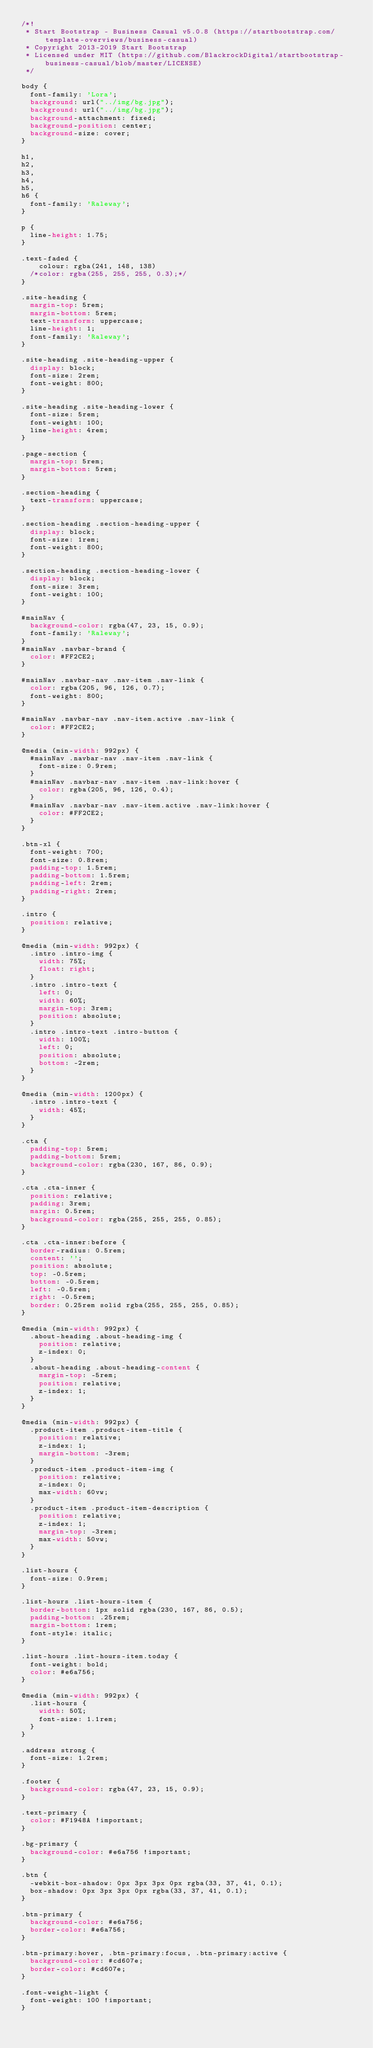Convert code to text. <code><loc_0><loc_0><loc_500><loc_500><_CSS_>/*!
 * Start Bootstrap - Business Casual v5.0.8 (https://startbootstrap.com/template-overviews/business-casual)
 * Copyright 2013-2019 Start Bootstrap
 * Licensed under MIT (https://github.com/BlackrockDigital/startbootstrap-business-casual/blob/master/LICENSE)
 */

body {
  font-family: 'Lora';
  background: url("../img/bg.jpg");
  background: url("../img/bg.jpg");
  background-attachment: fixed;
  background-position: center;
  background-size: cover;
}

h1,
h2,
h3,
h4,
h5,
h6 {
  font-family: 'Raleway';
}

p {
  line-height: 1.75;
}

.text-faded {
	colour: rgba(241, 148, 138)
  /*color: rgba(255, 255, 255, 0.3);*/  
}

.site-heading {
  margin-top: 5rem;
  margin-bottom: 5rem;
  text-transform: uppercase;
  line-height: 1;
  font-family: 'Raleway';
}

.site-heading .site-heading-upper {
  display: block;
  font-size: 2rem;
  font-weight: 800;
}

.site-heading .site-heading-lower {
  font-size: 5rem;
  font-weight: 100;
  line-height: 4rem;
}

.page-section {
  margin-top: 5rem;
  margin-bottom: 5rem;
}

.section-heading {
  text-transform: uppercase;
}

.section-heading .section-heading-upper {
  display: block;
  font-size: 1rem;
  font-weight: 800;
}

.section-heading .section-heading-lower {
  display: block;
  font-size: 3rem;
  font-weight: 100;
}

#mainNav {
  background-color: rgba(47, 23, 15, 0.9);
  font-family: 'Raleway';
}
#mainNav .navbar-brand {
  color: #FF2CE2;
}

#mainNav .navbar-nav .nav-item .nav-link {
  color: rgba(205, 96, 126, 0.7);
  font-weight: 800;
}

#mainNav .navbar-nav .nav-item.active .nav-link {
  color: #FF2CE2;
}

@media (min-width: 992px) {
  #mainNav .navbar-nav .nav-item .nav-link {
    font-size: 0.9rem;
  }
  #mainNav .navbar-nav .nav-item .nav-link:hover {
    color: rgba(205, 96, 126, 0.4);
  }
  #mainNav .navbar-nav .nav-item.active .nav-link:hover {
    color: #FF2CE2;
  }
}

.btn-xl {
  font-weight: 700;
  font-size: 0.8rem;
  padding-top: 1.5rem;
  padding-bottom: 1.5rem;
  padding-left: 2rem;
  padding-right: 2rem;
}

.intro {
  position: relative;
}

@media (min-width: 992px) {
  .intro .intro-img {
    width: 75%;
    float: right;
  }
  .intro .intro-text {
    left: 0;
    width: 60%;
    margin-top: 3rem;
    position: absolute;
  }
  .intro .intro-text .intro-button {
    width: 100%;
    left: 0;
    position: absolute;
    bottom: -2rem;
  }
}

@media (min-width: 1200px) {
  .intro .intro-text {
    width: 45%;
  }
}

.cta {
  padding-top: 5rem;
  padding-bottom: 5rem;
  background-color: rgba(230, 167, 86, 0.9);
}

.cta .cta-inner {
  position: relative;
  padding: 3rem;
  margin: 0.5rem;
  background-color: rgba(255, 255, 255, 0.85);
}

.cta .cta-inner:before {
  border-radius: 0.5rem;
  content: '';
  position: absolute;
  top: -0.5rem;
  bottom: -0.5rem;
  left: -0.5rem;
  right: -0.5rem;
  border: 0.25rem solid rgba(255, 255, 255, 0.85);
}

@media (min-width: 992px) {
  .about-heading .about-heading-img {
    position: relative;
    z-index: 0;
  }
  .about-heading .about-heading-content {
    margin-top: -5rem;
    position: relative;
    z-index: 1;
  }
}

@media (min-width: 992px) {
  .product-item .product-item-title {
    position: relative;
    z-index: 1;
    margin-bottom: -3rem;
  }
  .product-item .product-item-img {
    position: relative;
    z-index: 0;
    max-width: 60vw;
  }
  .product-item .product-item-description {
    position: relative;
    z-index: 1;
    margin-top: -3rem;
    max-width: 50vw;
  }
}

.list-hours {
  font-size: 0.9rem;
}

.list-hours .list-hours-item {
  border-bottom: 1px solid rgba(230, 167, 86, 0.5);
  padding-bottom: .25rem;
  margin-bottom: 1rem;
  font-style: italic;
}

.list-hours .list-hours-item.today {
  font-weight: bold;
  color: #e6a756;
}

@media (min-width: 992px) {
  .list-hours {
    width: 50%;
    font-size: 1.1rem;
  }
}

.address strong {
  font-size: 1.2rem;
}

.footer {
  background-color: rgba(47, 23, 15, 0.9);
}

.text-primary {
  color: #F1948A !important;
}

.bg-primary {
  background-color: #e6a756 !important;
}

.btn {
  -webkit-box-shadow: 0px 3px 3px 0px rgba(33, 37, 41, 0.1);
  box-shadow: 0px 3px 3px 0px rgba(33, 37, 41, 0.1);
}

.btn-primary {
  background-color: #e6a756;
  border-color: #e6a756;
}

.btn-primary:hover, .btn-primary:focus, .btn-primary:active {
  background-color: #cd607e;
  border-color: #cd607e;
}

.font-weight-light {
  font-weight: 100 !important;
}
</code> 